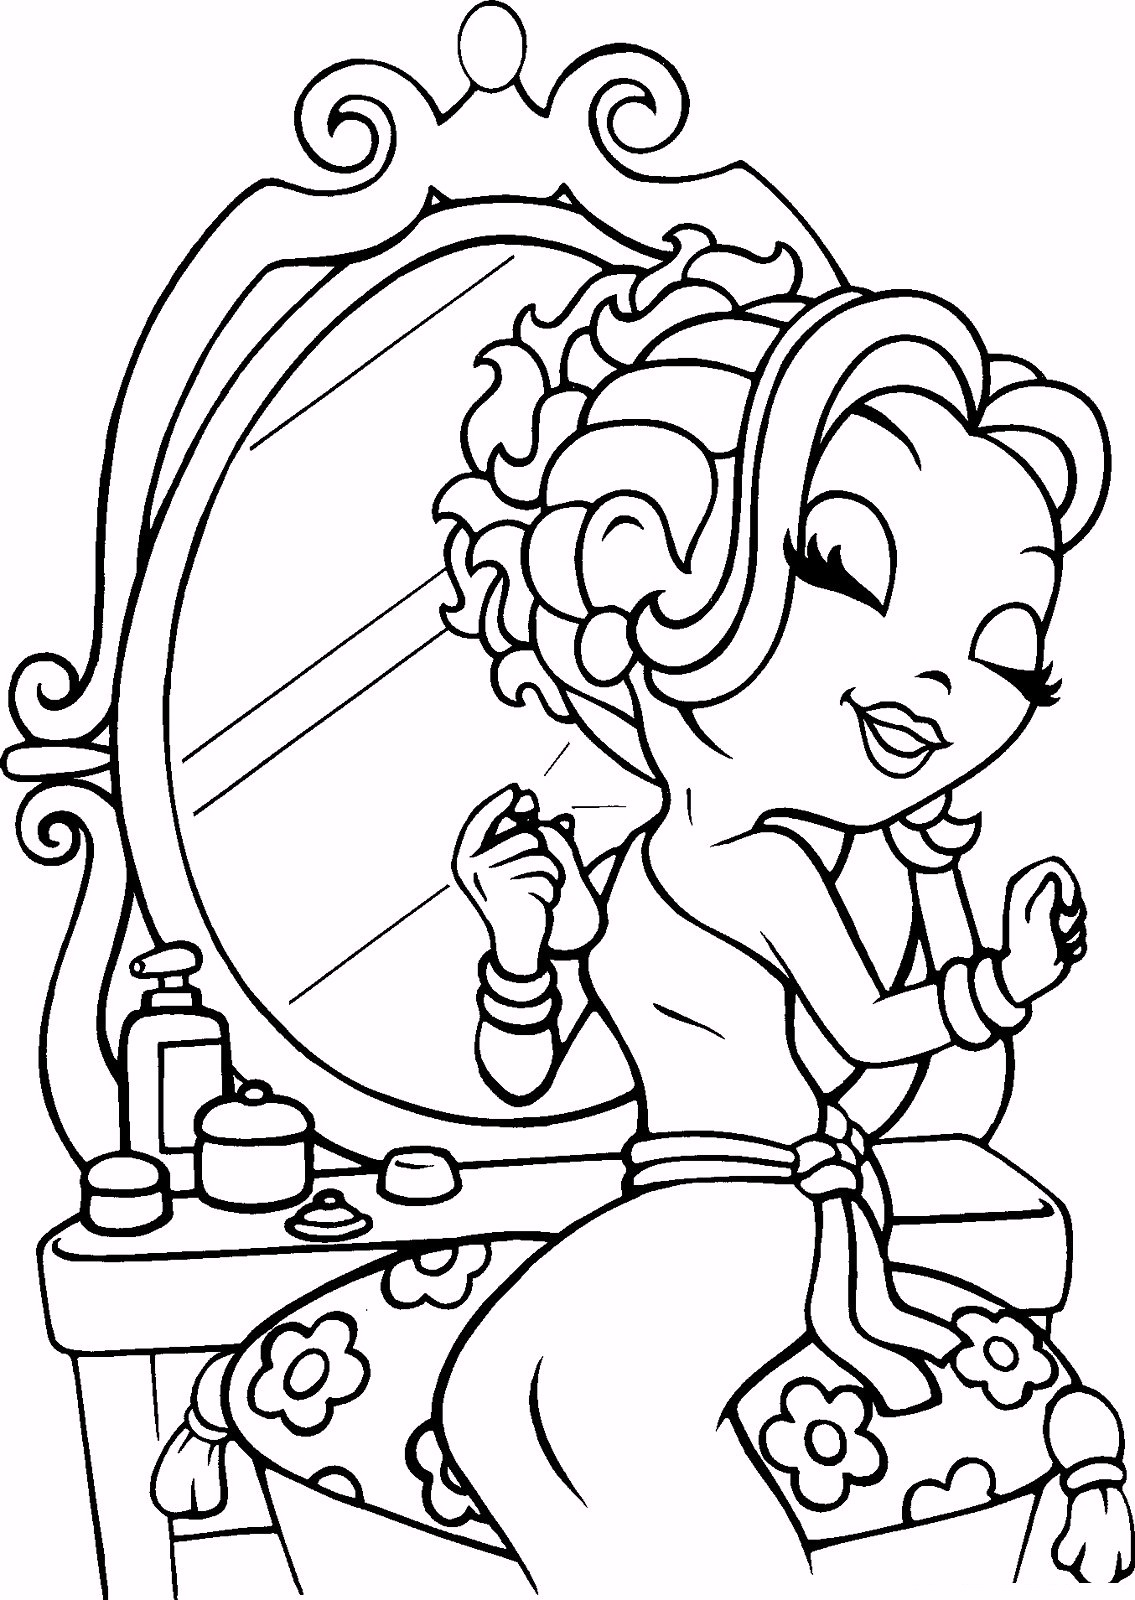If the girl were to give a beauty tutorial based on this scene, what steps might she include, and why are they significant? In a beauty tutorial based on this scene, the girl might include several key steps: 1. Cleaning the nails using cotton balls and nail polish remover to create a fresh base. 2. Moisturizing the cuticles with a cream to keep the skin soft and healthy. 3. Applying a base coat to protect the nails and give the polish a smooth foundation. 4. Painting the nails with the chosen nail polish color for a stylish look. 5. Finishing with a top coat to seal in the color and add shine. Each step is significant because it ensures a long-lasting, professional-looking manicure while caring for the health of the nails and cuticles. What if there was a magical bottle on the table that could transform her nails instantly to any design she imagined? Describe how she would use it and what designs she might create. If there were a magical bottle on the table that could transform her nails to any design she imagined, the girl would likely be thrilled to use it. She would simply open the bottle, think of her desired nail design, and watch in amazement as the magic took over. She might first try a classic French manicure, with perfect white tips and a smooth pink base. Then, she could transform her nails into a dazzling ombre pattern that fades from deep purple to glittery gold. Feeling adventurous, she might envision a set of nails adorned with intricate floral patterns, each petal meticulously detailed. For a special occasion, she could imagine her nails decorated with tiny, sparkling gems forming elegant patterns. The possibilities would be endless, limited only by her creativity, allowing her to showcase a new and unique design every day. 